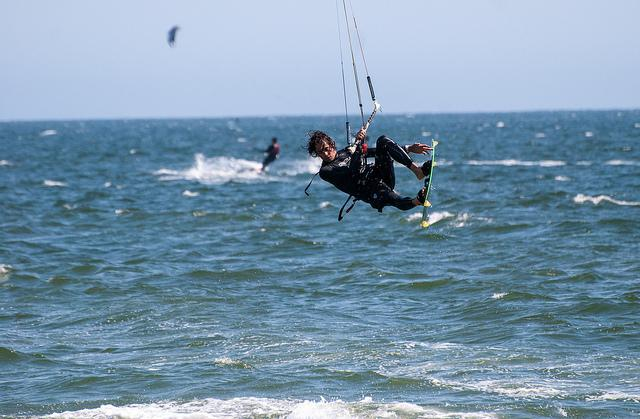What is above this person? Please explain your reasoning. parasail. Based on the equipment the person is using and the harness they are strapped into, the object above them at the other end of the straps would be answer a. 